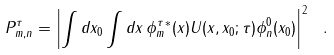<formula> <loc_0><loc_0><loc_500><loc_500>P _ { m , n } ^ { \tau } = \left | \int d x _ { 0 } \int d x \, { \phi _ { m } ^ { \tau } } ^ { * } ( x ) U ( x , x _ { 0 } ; \tau ) \phi ^ { 0 } _ { n } ( x _ { 0 } ) \right | ^ { 2 } \ .</formula> 